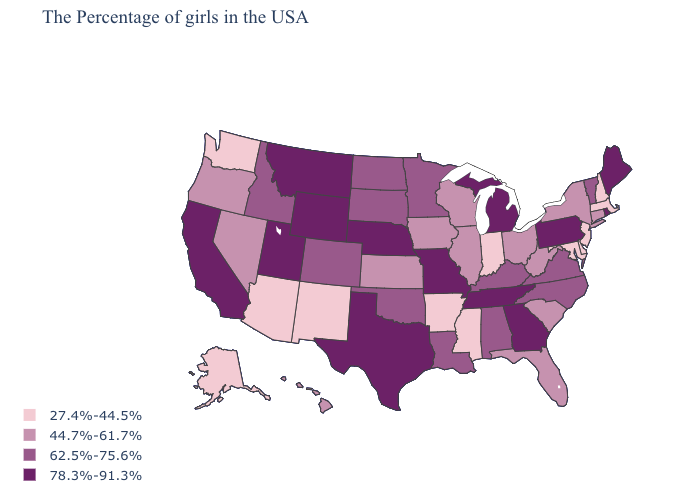Among the states that border Texas , does Louisiana have the lowest value?
Short answer required. No. What is the lowest value in states that border Rhode Island?
Keep it brief. 27.4%-44.5%. What is the lowest value in states that border West Virginia?
Answer briefly. 27.4%-44.5%. Does Utah have the highest value in the West?
Keep it brief. Yes. Does the first symbol in the legend represent the smallest category?
Answer briefly. Yes. What is the highest value in the USA?
Quick response, please. 78.3%-91.3%. Among the states that border Kansas , which have the lowest value?
Short answer required. Oklahoma, Colorado. What is the value of New York?
Keep it brief. 44.7%-61.7%. Which states hav the highest value in the Northeast?
Short answer required. Maine, Rhode Island, Pennsylvania. What is the value of Vermont?
Write a very short answer. 62.5%-75.6%. What is the value of Kentucky?
Concise answer only. 62.5%-75.6%. What is the value of Oklahoma?
Short answer required. 62.5%-75.6%. Which states have the lowest value in the USA?
Be succinct. Massachusetts, New Hampshire, New Jersey, Delaware, Maryland, Indiana, Mississippi, Arkansas, New Mexico, Arizona, Washington, Alaska. Among the states that border Pennsylvania , which have the highest value?
Be succinct. New York, West Virginia, Ohio. Which states have the lowest value in the USA?
Short answer required. Massachusetts, New Hampshire, New Jersey, Delaware, Maryland, Indiana, Mississippi, Arkansas, New Mexico, Arizona, Washington, Alaska. 